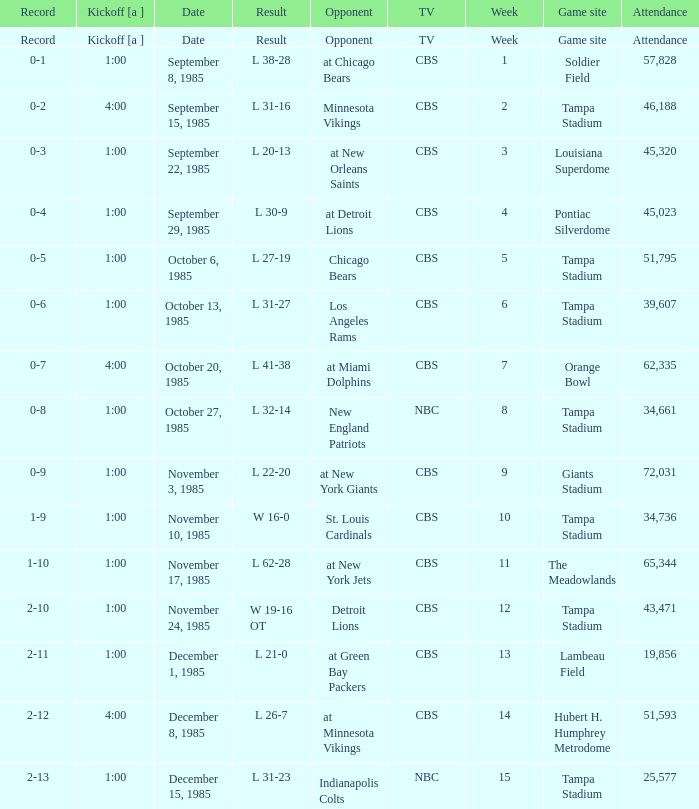Give me the kickoff time of the game that was aired on CBS against the St. Louis Cardinals.  1:00. 